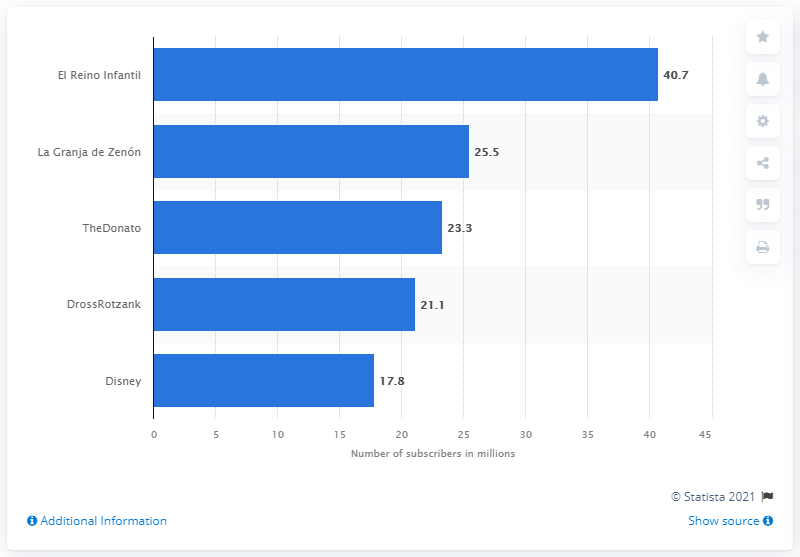List a handful of essential elements in this visual. As of March 2021, El Reino Infantil had 40,700 subscribers. As of March 2021, El Reino Infantil was the leading YouTube channel in Argentina. La Granja de Zen3n had 25.5 subscribers. 